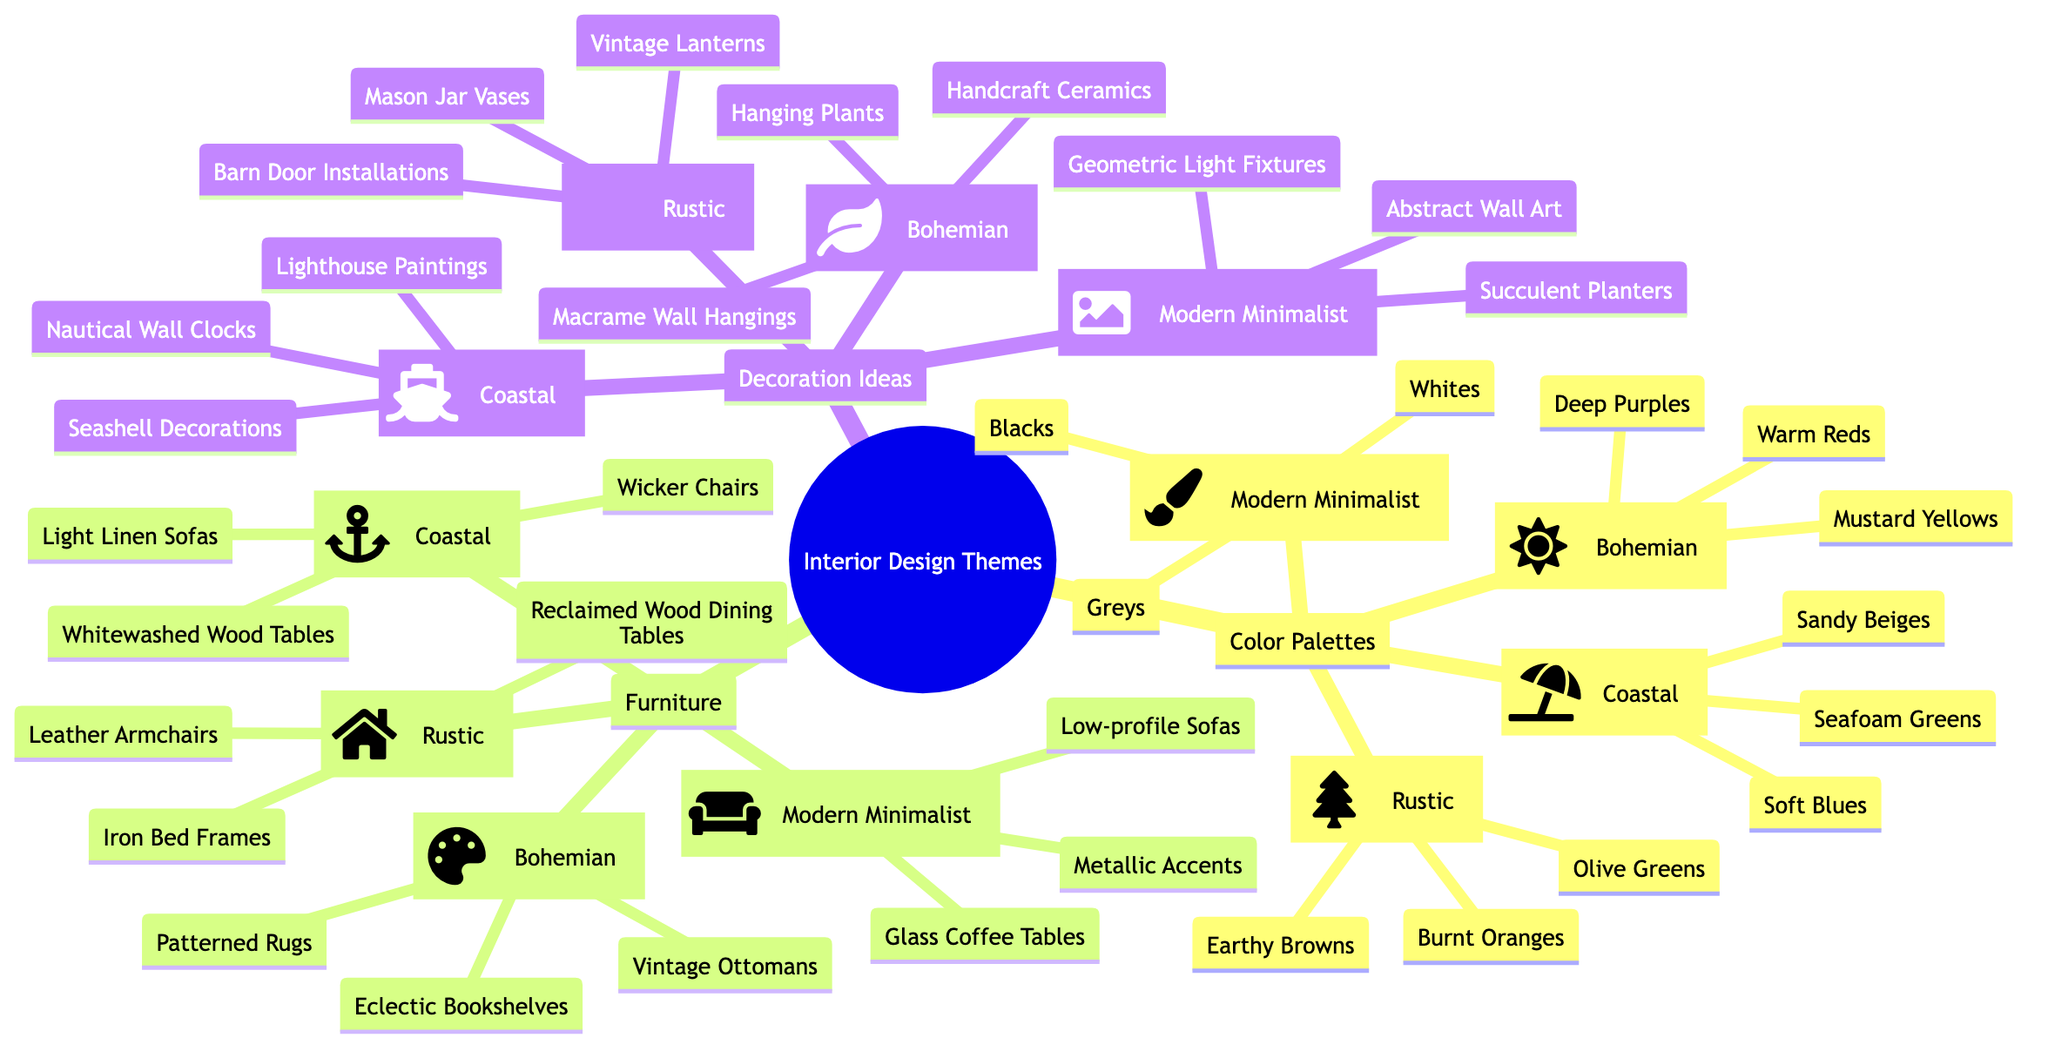What color palette is associated with Coastal design? The diagram indicates that the Coastal design theme includes the color palette of Soft Blues, Sandy Beiges, and Seafoam Greens. Therefore, the answer is derived directly from the Coastal section under Color Palettes.
Answer: Soft Blues, Sandy Beiges, Seafoam Greens Which furniture style is part of the Rustic theme? According to the diagram, the Rustic theme features furniture styles such as Reclaimed Wood Dining Tables, Leather Armchairs, and Iron Bed Frames. The answer is found by looking at the Rustic section under Furniture.
Answer: Reclaimed Wood Dining Tables, Leather Armchairs, Iron Bed Frames How many different decoration ideas are there under Bohemian? The Bohemian section under Decoration Ideas lists Macrame Wall Hangings, Hanging Plants, and Handcraft Ceramics, totaling three decoration ideas. The answer is calculated by counting the elements in that category.
Answer: 3 What is a common element between Modern Minimalist color palette and furniture style? By examining both the Modern Minimalist sections of Color Palettes and Furniture, one finds that both convey simplicity and neutrality, with Whites and Greys in the palette and Low-profile Sofas in furniture. The reasoning is based on the shared aesthetic and design principle of Minimalism.
Answer: Simplicity Which theme features Nautical Wall Clocks in decoration ideas? The Nautical Wall Clocks are specifically listed under the Coastal theme in Decoration Ideas. By checking this section, one can verify that Nautical Wall Clocks align with the Coastal design theme.
Answer: Coastal How many themes are represented in the mind map? The mind map displays four distinct interior design themes: Modern Minimalist, Coastal, Rustic, and Bohemian. The answer comes from counting the individual theme nodes under Interior Design Themes.
Answer: 4 List one decoration idea from the Rustic theme. The Rustic theme decoration ideas include Mason Jar Vases, Barn Door Installations, and Vintage Lanterns. By checking the Rustic section under Decoration Ideas, any of these can be chosen as an answer.
Answer: Mason Jar Vases Which theme incorporates Hanging Plants in its decoration? By reviewing the Decoration Ideas, Hanging Plants are specified in the Bohemian section, indicating that this decoration idea is unique to the Bohemian theme. The conclusion comes directly from identifying the relevant section.
Answer: Bohemian 